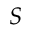Convert formula to latex. <formula><loc_0><loc_0><loc_500><loc_500>S</formula> 